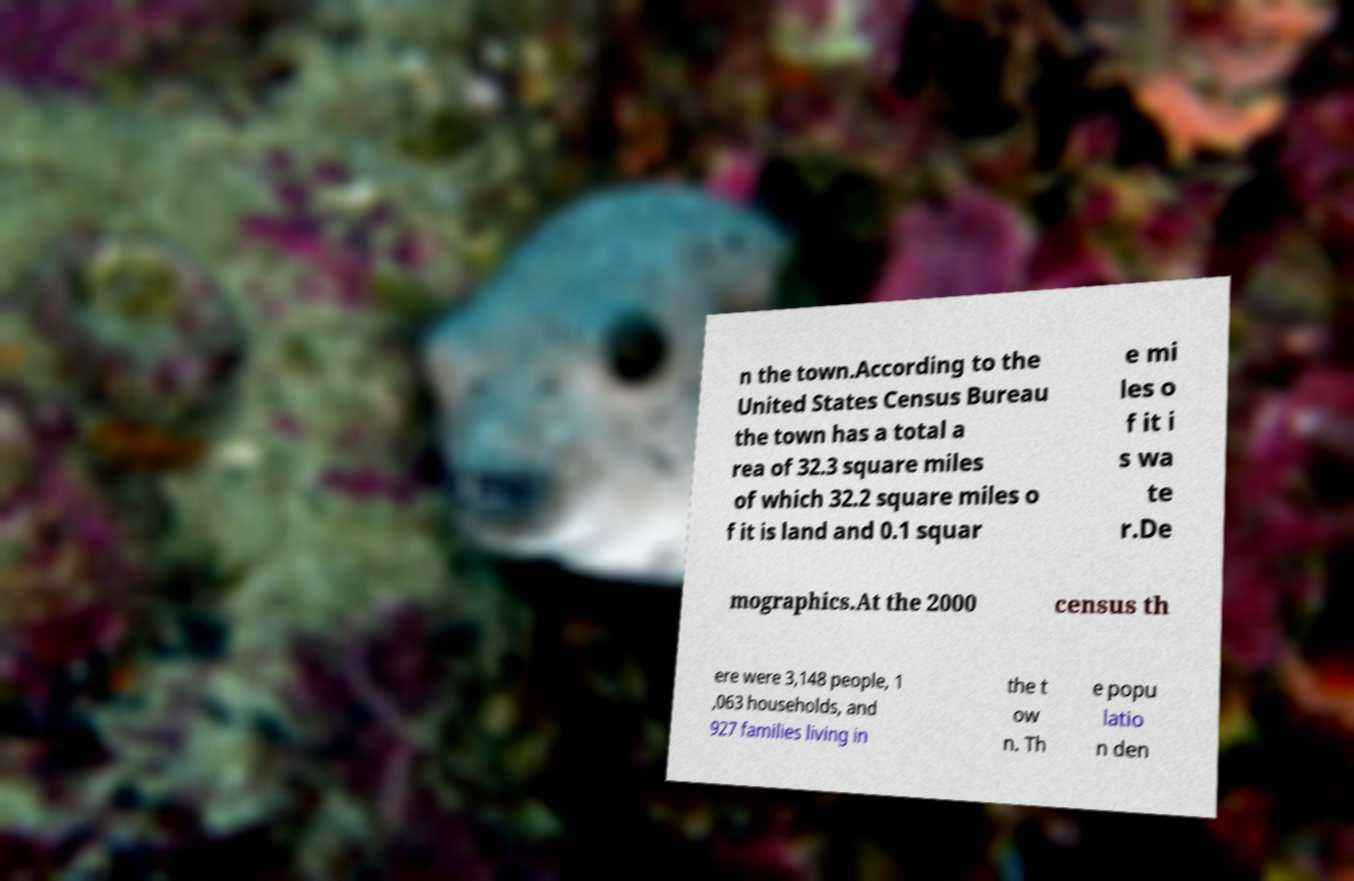Could you assist in decoding the text presented in this image and type it out clearly? n the town.According to the United States Census Bureau the town has a total a rea of 32.3 square miles of which 32.2 square miles o f it is land and 0.1 squar e mi les o f it i s wa te r.De mographics.At the 2000 census th ere were 3,148 people, 1 ,063 households, and 927 families living in the t ow n. Th e popu latio n den 